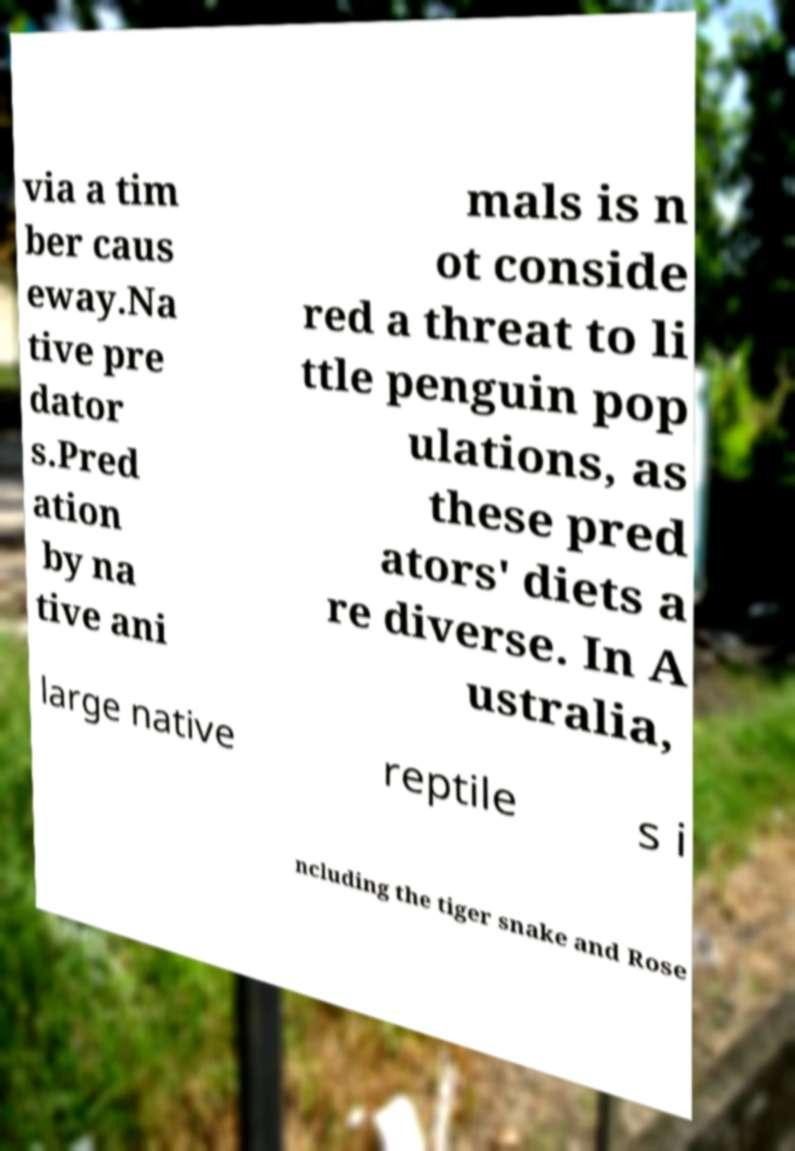Can you read and provide the text displayed in the image?This photo seems to have some interesting text. Can you extract and type it out for me? via a tim ber caus eway.Na tive pre dator s.Pred ation by na tive ani mals is n ot conside red a threat to li ttle penguin pop ulations, as these pred ators' diets a re diverse. In A ustralia, large native reptile s i ncluding the tiger snake and Rose 